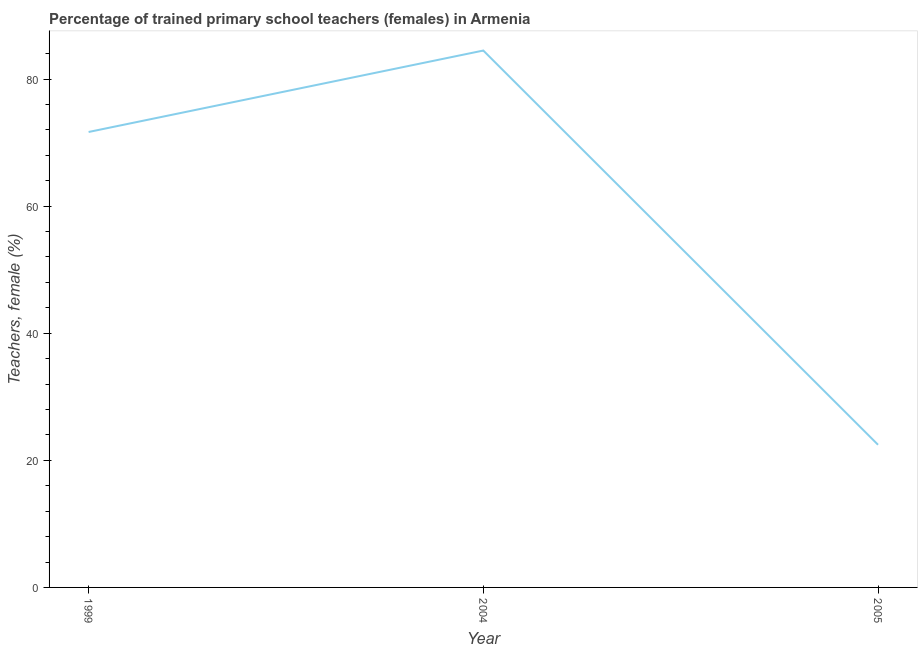What is the percentage of trained female teachers in 1999?
Keep it short and to the point. 71.67. Across all years, what is the maximum percentage of trained female teachers?
Your answer should be compact. 84.48. Across all years, what is the minimum percentage of trained female teachers?
Give a very brief answer. 22.45. In which year was the percentage of trained female teachers maximum?
Provide a short and direct response. 2004. In which year was the percentage of trained female teachers minimum?
Your answer should be compact. 2005. What is the sum of the percentage of trained female teachers?
Your answer should be very brief. 178.6. What is the difference between the percentage of trained female teachers in 2004 and 2005?
Ensure brevity in your answer.  62.03. What is the average percentage of trained female teachers per year?
Keep it short and to the point. 59.53. What is the median percentage of trained female teachers?
Ensure brevity in your answer.  71.67. What is the ratio of the percentage of trained female teachers in 2004 to that in 2005?
Provide a short and direct response. 3.76. Is the difference between the percentage of trained female teachers in 1999 and 2004 greater than the difference between any two years?
Your answer should be very brief. No. What is the difference between the highest and the second highest percentage of trained female teachers?
Your answer should be compact. 12.82. What is the difference between the highest and the lowest percentage of trained female teachers?
Keep it short and to the point. 62.03. Does the percentage of trained female teachers monotonically increase over the years?
Offer a very short reply. No. Are the values on the major ticks of Y-axis written in scientific E-notation?
Offer a very short reply. No. What is the title of the graph?
Make the answer very short. Percentage of trained primary school teachers (females) in Armenia. What is the label or title of the X-axis?
Give a very brief answer. Year. What is the label or title of the Y-axis?
Provide a succinct answer. Teachers, female (%). What is the Teachers, female (%) of 1999?
Your answer should be compact. 71.67. What is the Teachers, female (%) in 2004?
Provide a succinct answer. 84.48. What is the Teachers, female (%) of 2005?
Your response must be concise. 22.45. What is the difference between the Teachers, female (%) in 1999 and 2004?
Offer a terse response. -12.82. What is the difference between the Teachers, female (%) in 1999 and 2005?
Your answer should be very brief. 49.22. What is the difference between the Teachers, female (%) in 2004 and 2005?
Keep it short and to the point. 62.03. What is the ratio of the Teachers, female (%) in 1999 to that in 2004?
Provide a short and direct response. 0.85. What is the ratio of the Teachers, female (%) in 1999 to that in 2005?
Give a very brief answer. 3.19. What is the ratio of the Teachers, female (%) in 2004 to that in 2005?
Your response must be concise. 3.76. 